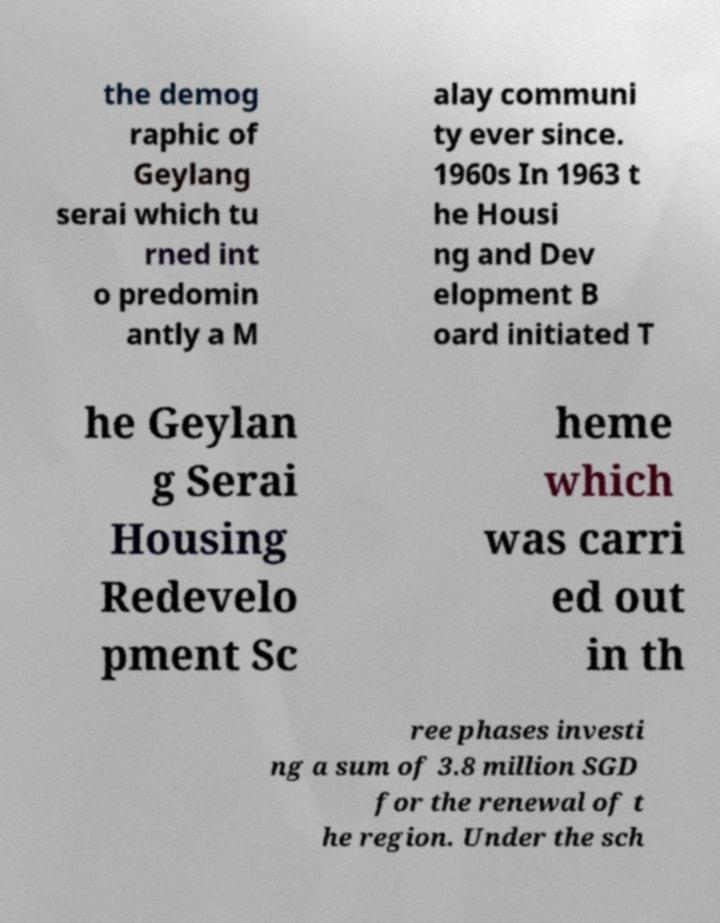I need the written content from this picture converted into text. Can you do that? the demog raphic of Geylang serai which tu rned int o predomin antly a M alay communi ty ever since. 1960s In 1963 t he Housi ng and Dev elopment B oard initiated T he Geylan g Serai Housing Redevelo pment Sc heme which was carri ed out in th ree phases investi ng a sum of 3.8 million SGD for the renewal of t he region. Under the sch 